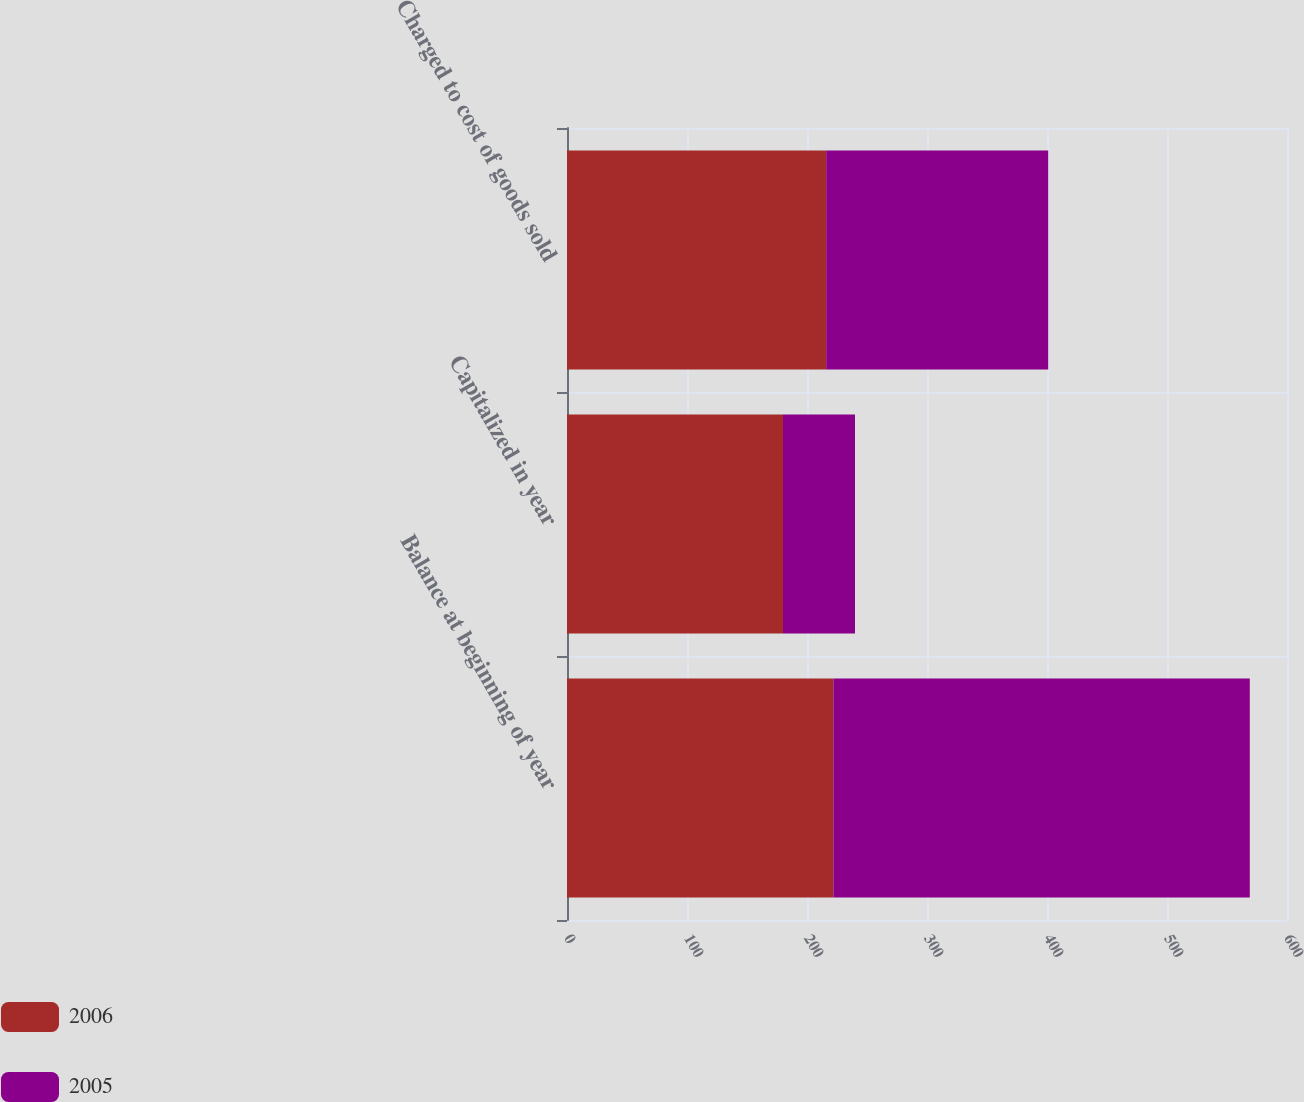<chart> <loc_0><loc_0><loc_500><loc_500><stacked_bar_chart><ecel><fcel>Balance at beginning of year<fcel>Capitalized in year<fcel>Charged to cost of goods sold<nl><fcel>2006<fcel>222<fcel>180<fcel>216<nl><fcel>2005<fcel>347<fcel>60<fcel>185<nl></chart> 